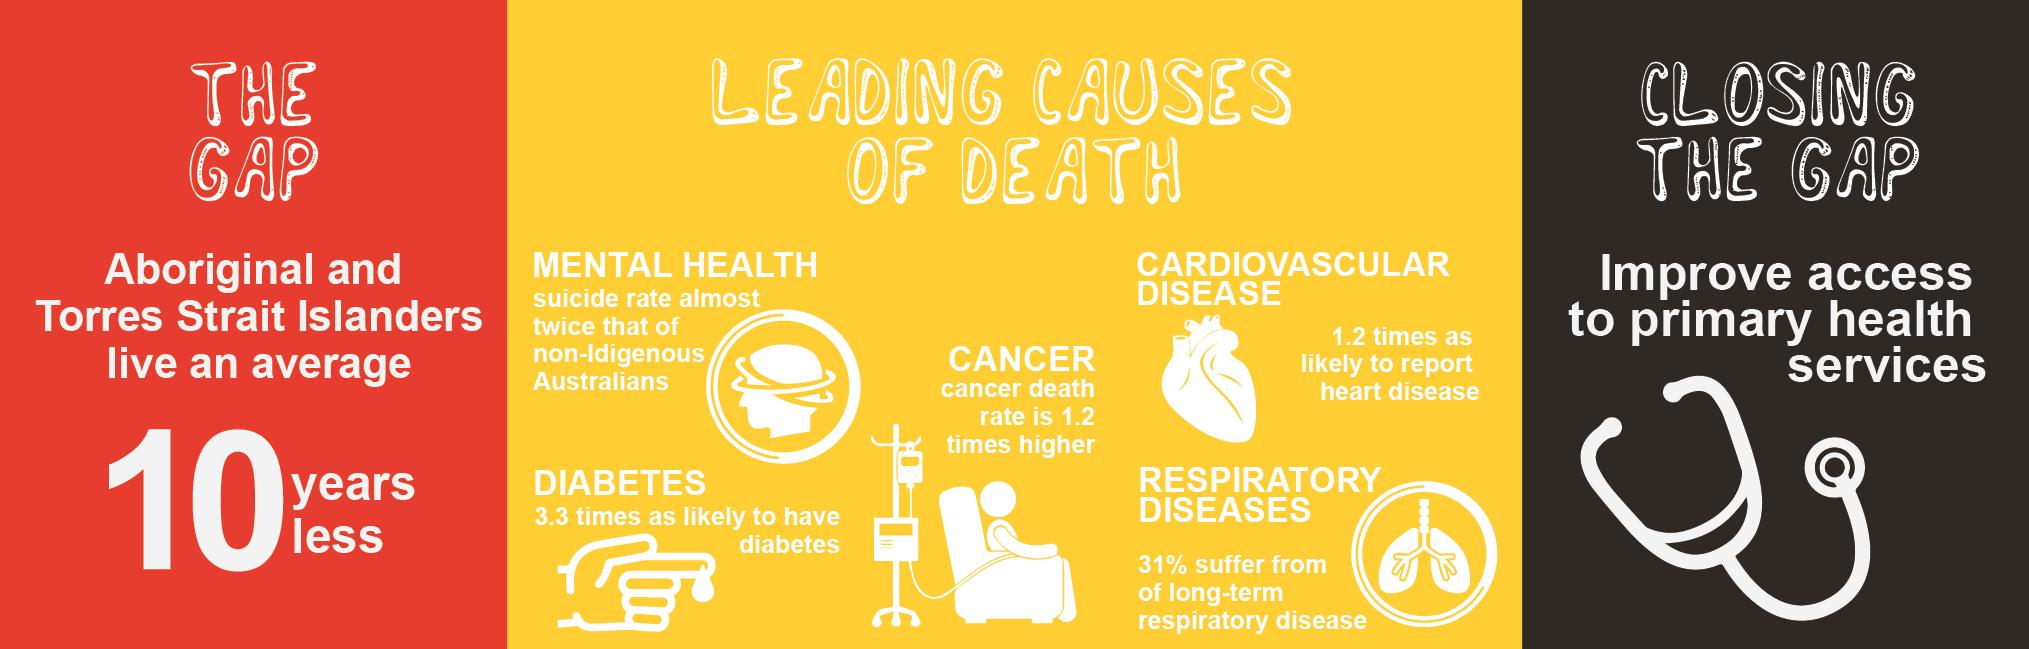Outline some significant characteristics in this image. There are five different causes of death listed in the infographic. 